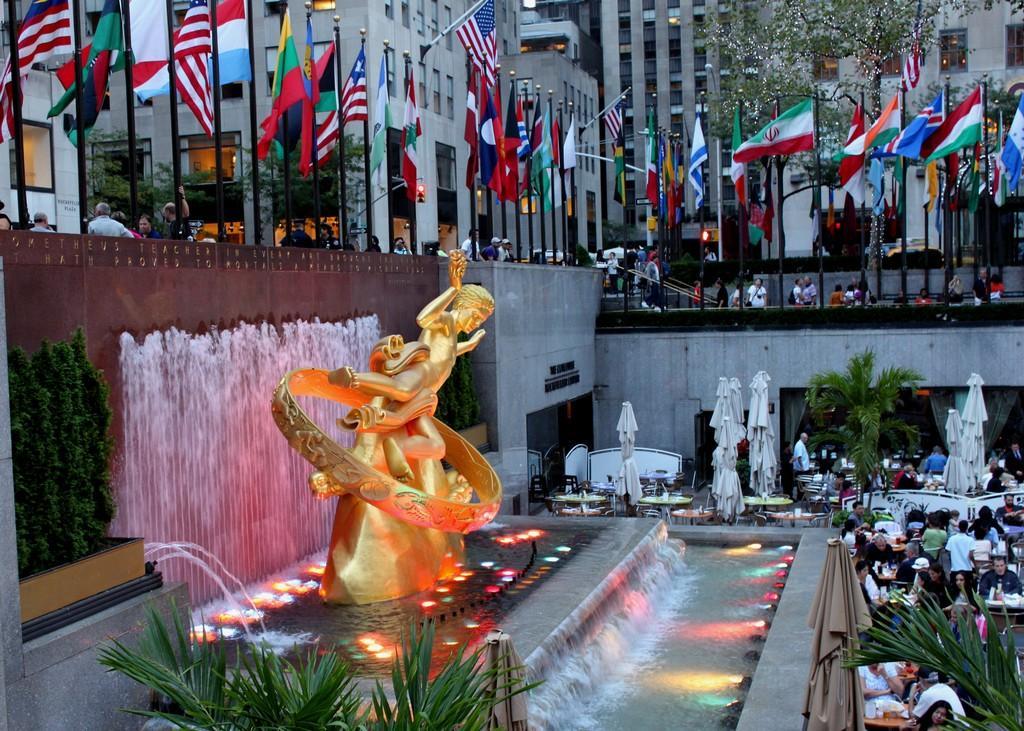In one or two sentences, can you explain what this image depicts? In this image I can see there are buildings and in front of the building there are persons and flags attached to it. And there are trees. And at the bottom there is a statue in waterfall with lights. And there are persons sitting on the chair. And there is a table with some objects. And at the side there is a cloth which is tied to the rod. 